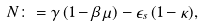<formula> <loc_0><loc_0><loc_500><loc_500>N \colon = \gamma \, ( 1 - \beta \, \mu ) - \epsilon _ { s } \, ( 1 - \kappa ) ,</formula> 